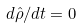Convert formula to latex. <formula><loc_0><loc_0><loc_500><loc_500>d { \hat { \rho } } / d t = 0</formula> 